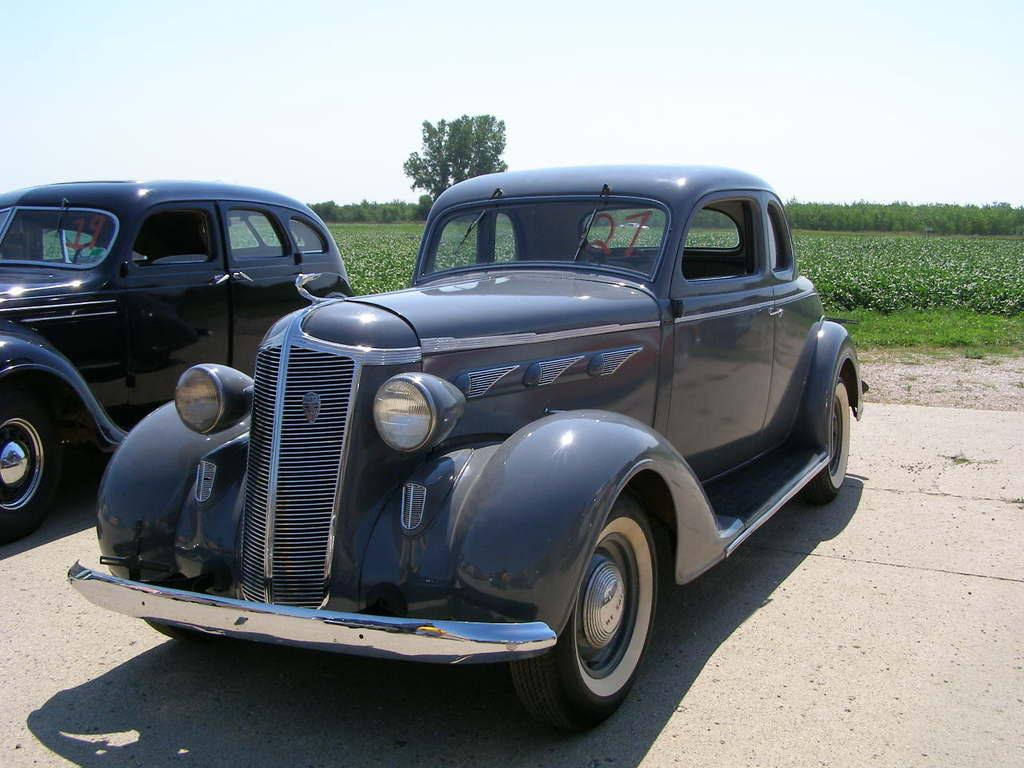What vehicles are in the foreground of the image? There are two cars in the foreground of the image. What is located at the bottom of the image? There is a road at the bottom of the image. What type of vegetation can be seen in the background of the image? There are plants and trees in the background of the image. What is visible at the top of the image? The sky is visible at the top of the image. Where is the hydrant located in the image? There is no hydrant present in the image. What type of architectural feature is visible in the image? There is no specific architectural feature mentioned in the provided facts, but the image does show a road and trees. Can you tell me how many airplanes are visible in the image? There is no mention of airplanes or an airport in the provided facts, so it cannot be determined from the image. 